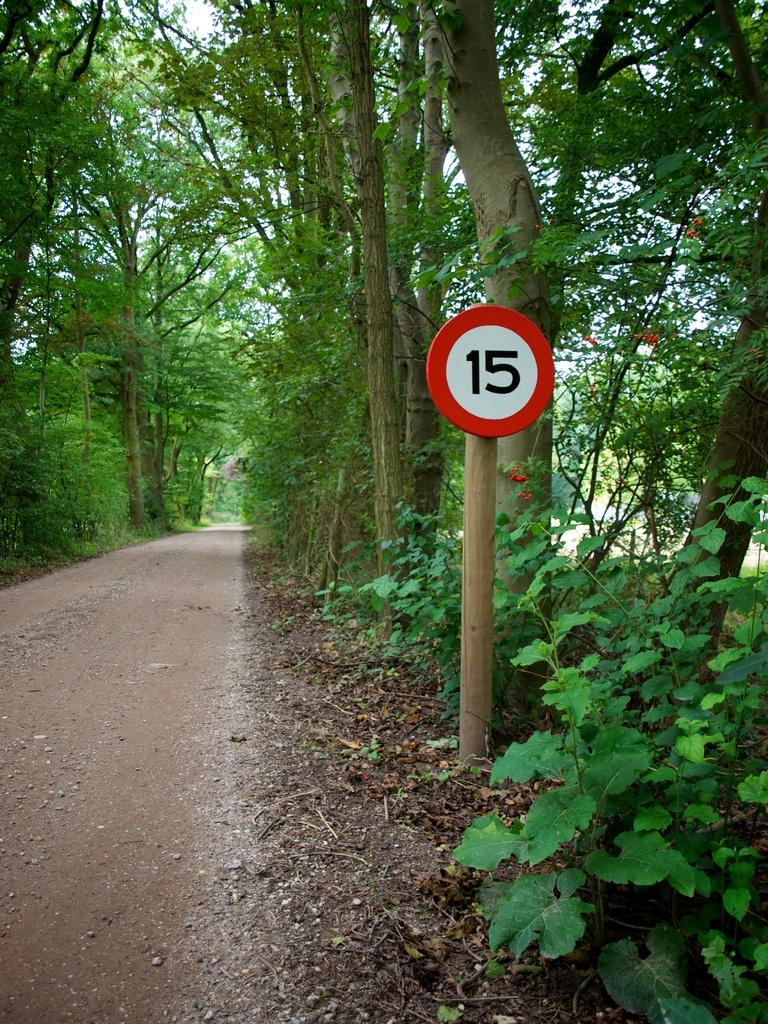<image>
Present a compact description of the photo's key features. the number 15 on a tree with wood under it 